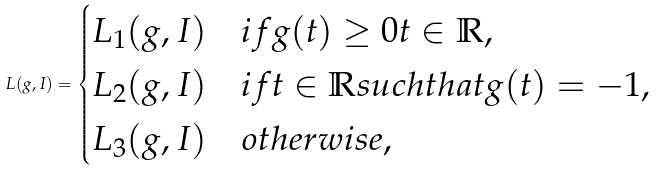<formula> <loc_0><loc_0><loc_500><loc_500>L ( g , I ) = \begin{cases} L _ { 1 } ( g , I ) & i f g ( t ) \geq 0 t \in \mathbb { R } , \\ L _ { 2 } ( g , I ) & i f t \in \mathbb { R } s u c h t h a t g ( t ) = - 1 , \\ L _ { 3 } ( g , I ) & o t h e r w i s e , \end{cases}</formula> 